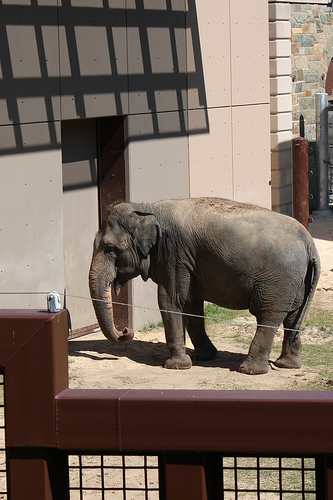<image>
Is there a elephant behind the wall? No. The elephant is not behind the wall. From this viewpoint, the elephant appears to be positioned elsewhere in the scene. 